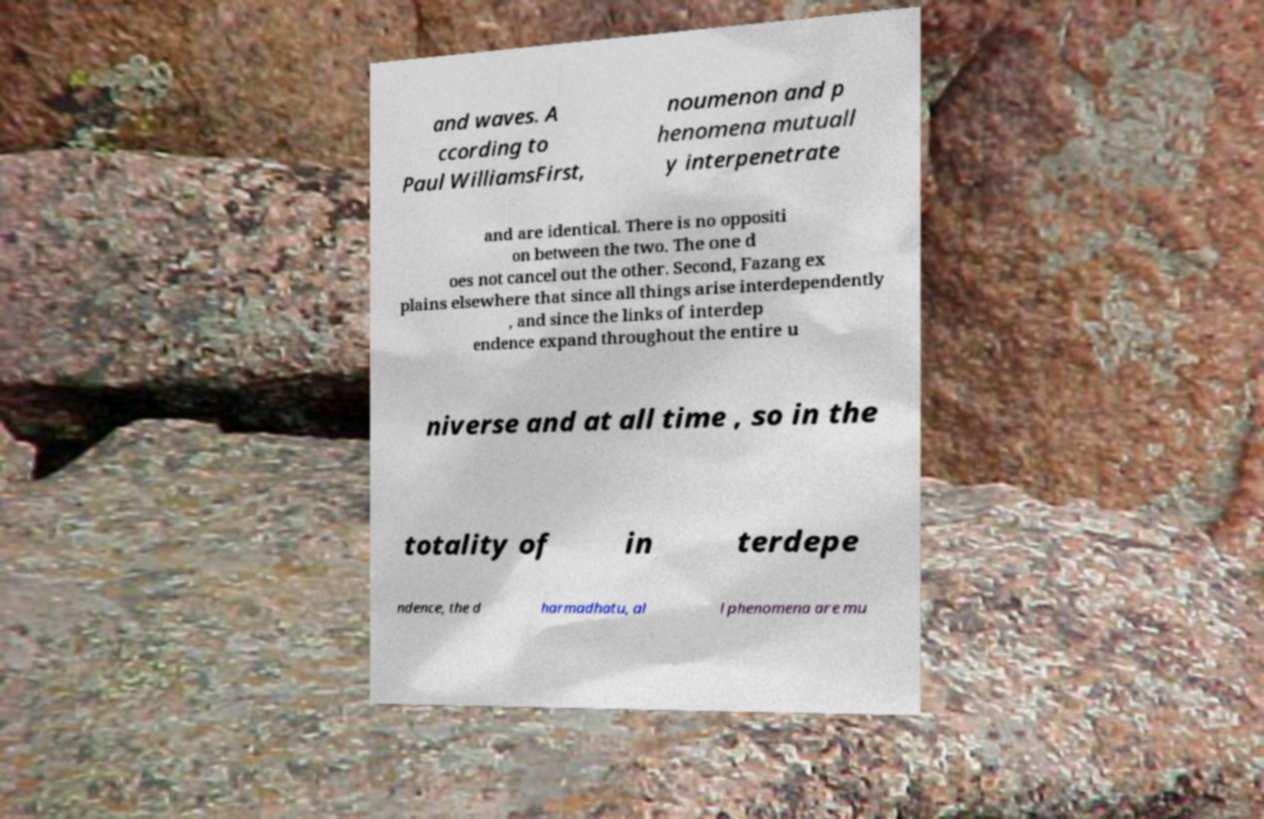I need the written content from this picture converted into text. Can you do that? and waves. A ccording to Paul WilliamsFirst, noumenon and p henomena mutuall y interpenetrate and are identical. There is no oppositi on between the two. The one d oes not cancel out the other. Second, Fazang ex plains elsewhere that since all things arise interdependently , and since the links of interdep endence expand throughout the entire u niverse and at all time , so in the totality of in terdepe ndence, the d harmadhatu, al l phenomena are mu 